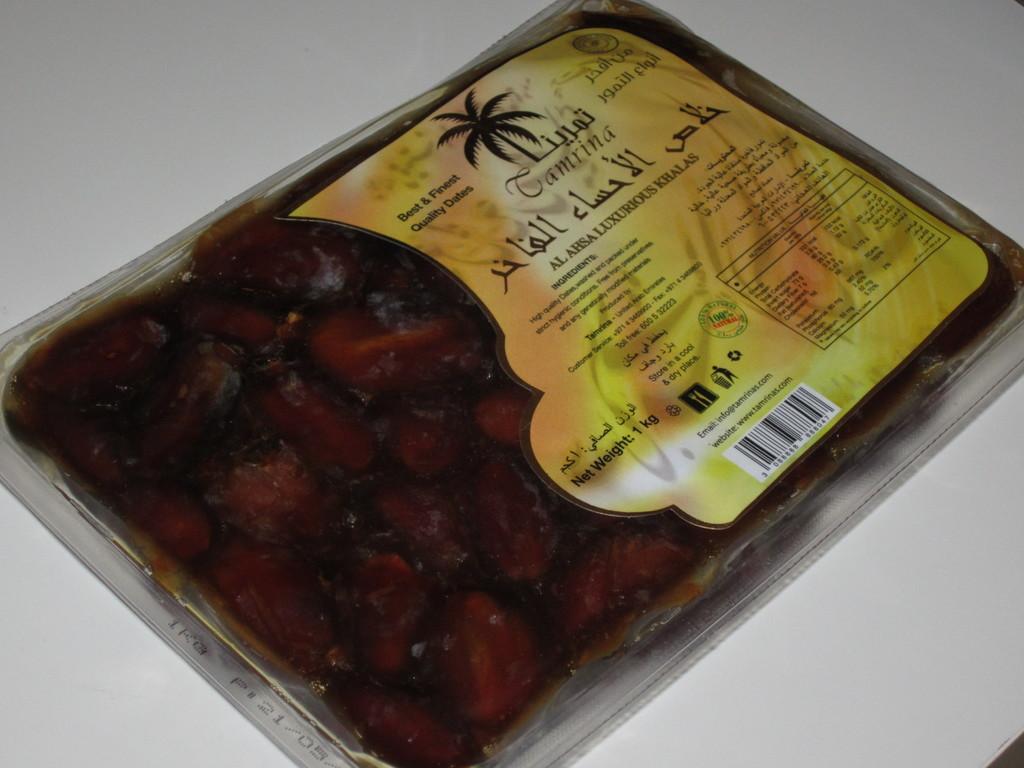Can you describe this image briefly? In the image we can see a food item wrapped in a cover. This is a tag on the food item and a surface white in color. 